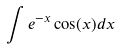Convert formula to latex. <formula><loc_0><loc_0><loc_500><loc_500>\int e ^ { - x } \cos ( x ) d x</formula> 